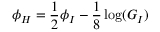<formula> <loc_0><loc_0><loc_500><loc_500>\phi _ { H } = \frac { 1 } { 2 } \phi _ { I } - \frac { 1 } { 8 } \log ( G _ { I } )</formula> 